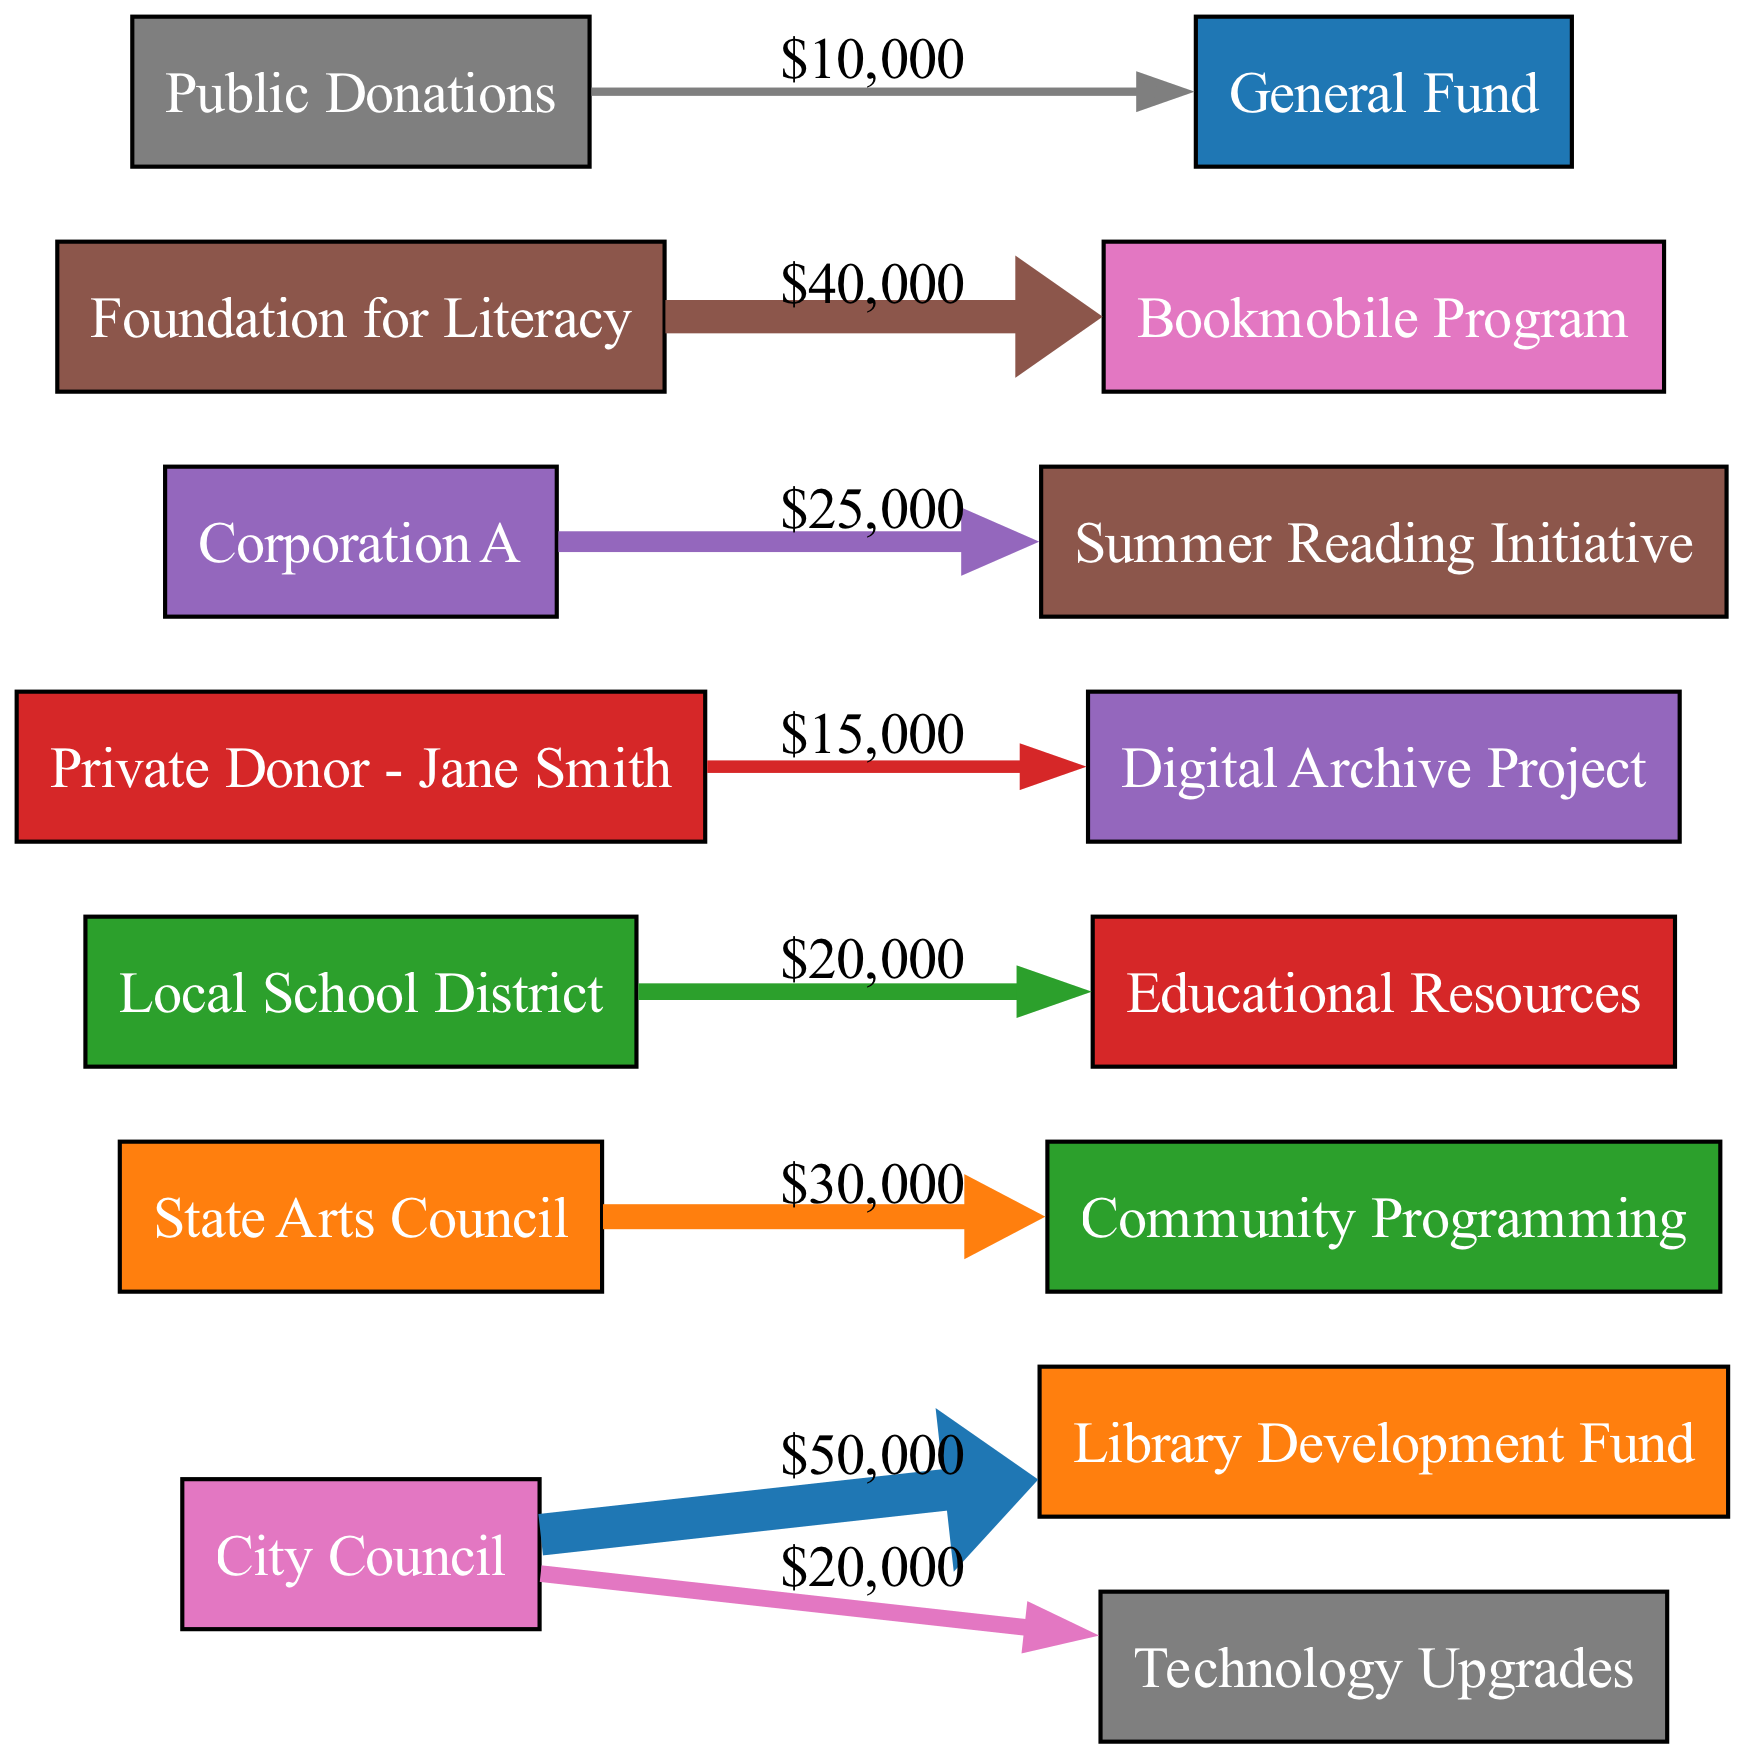What is the value of donations from the City Council? The diagram shows a flow from the City Council to the Library Development Fund with a value of 50000. This can be confirmed by locating the City Council node and checking the corresponding edge value.
Answer: 50000 How much funding is allocated to the Community Programming? By examining the edge from the State Arts Council to the Community Programming target, we find that the value indicated is 30000, which represents the allocated funding for this specific project.
Answer: 30000 Which project received donations from the Private Donor - Jane Smith? The diagram indicates a flow from the Private Donor - Jane Smith to the Digital Archive Project, clearly showing the relationship and allocation of funds.
Answer: Digital Archive Project What is the total value of public donations represented in the diagram? There is a flow from Public Donations to the General Fund with a value of 10000, thus this is the total amount represented in the diagram related to public donations.
Answer: 10000 Which source contributed the highest amount in this diagram? By comparing the values of all the sources within the diagram, the City Council contributed 50000, which is the highest value noted in the flows.
Answer: City Council How many distinct funding sources are represented in the diagram? Counting the unique nodes representing the sources (City Council, State Arts Council, Local School District, Private Donor - Jane Smith, Corporation A, Foundation for Literacy, Public Donations), we find there are 7 distinct sources.
Answer: 7 Which project received the largest single funding allocation? Analyzing the projects in the diagram, the Bookmobile Program received a funding allocation of 40000, which is the largest single amount allocated for a specific project.
Answer: Bookmobile Program What percentage of the total funding comes from Corporation A for its project? First, we identify the total funding number by summing all edge values, which amounts to 210000. Corporation A allocated 25000 for the Summer Reading Initiative. The percentage is then calculated as (25000 / 210000) * 100, resulting in approximately 11.9%.
Answer: 11.9% How many total project allocations are made by the City Council? From the diagram, we see that the City Council has two allocations: one to the Library Development Fund (50000) and another to Technology Upgrades (20000). Thus, the total number of project allocations by the City Council is two.
Answer: 2 